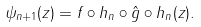Convert formula to latex. <formula><loc_0><loc_0><loc_500><loc_500>\psi _ { n + 1 } ( z ) = f \circ h _ { n } \circ \hat { g } \circ h _ { n } ( z ) .</formula> 